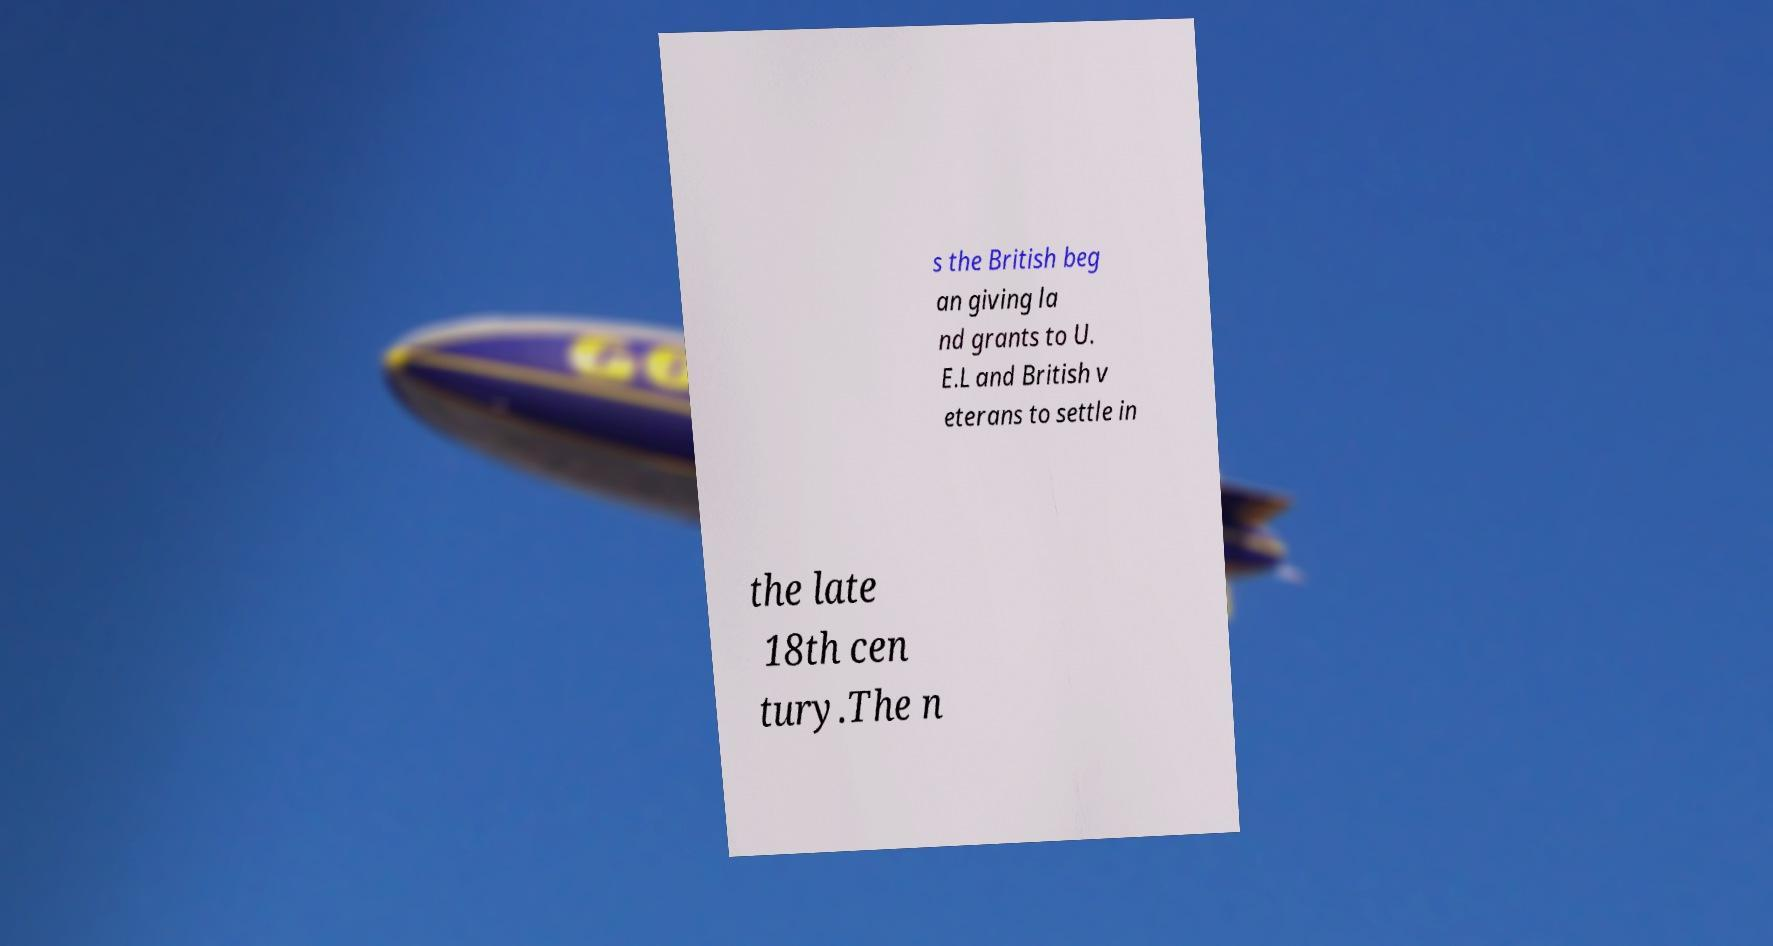What messages or text are displayed in this image? I need them in a readable, typed format. s the British beg an giving la nd grants to U. E.L and British v eterans to settle in the late 18th cen tury.The n 